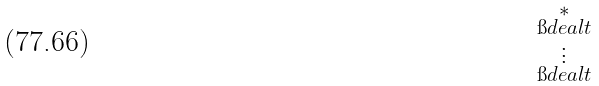Convert formula to latex. <formula><loc_0><loc_0><loc_500><loc_500>\begin{smallmatrix} * \\ \i d e a l { t } \\ \vdots \\ \i d e a l { t } \\ \end{smallmatrix}</formula> 